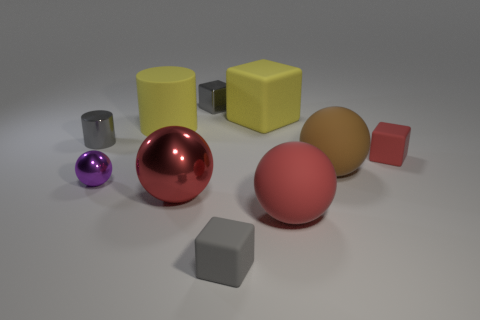The block to the right of the brown matte sphere that is behind the tiny gray thing that is on the right side of the metal cube is made of what material?
Your answer should be compact. Rubber. There is a metallic thing behind the gray cylinder; is it the same size as the big metallic sphere?
Your response must be concise. No. Are there more metallic spheres than green rubber cubes?
Offer a terse response. Yes. What number of large objects are either shiny objects or gray cubes?
Offer a very short reply. 1. How many other things are the same color as the tiny metallic block?
Provide a succinct answer. 2. What number of large blocks are the same material as the purple object?
Make the answer very short. 0. There is a metal ball that is right of the large yellow rubber cylinder; does it have the same color as the matte cylinder?
Your response must be concise. No. How many cyan things are small metal cubes or tiny shiny cylinders?
Keep it short and to the point. 0. Is there anything else that has the same material as the yellow block?
Keep it short and to the point. Yes. Is the material of the large yellow object that is on the right side of the large yellow rubber cylinder the same as the big brown thing?
Give a very brief answer. Yes. 